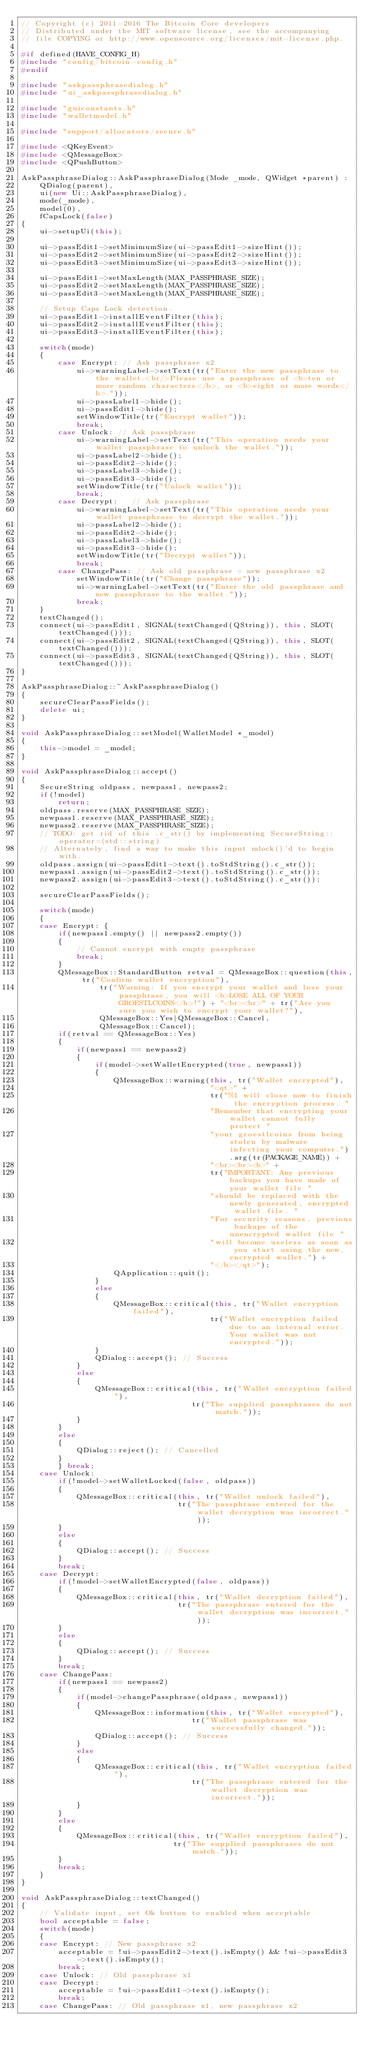Convert code to text. <code><loc_0><loc_0><loc_500><loc_500><_C++_>// Copyright (c) 2011-2016 The Bitcoin Core developers
// Distributed under the MIT software license, see the accompanying
// file COPYING or http://www.opensource.org/licenses/mit-license.php.

#if defined(HAVE_CONFIG_H)
#include "config/bitcoin-config.h"
#endif

#include "askpassphrasedialog.h"
#include "ui_askpassphrasedialog.h"

#include "guiconstants.h"
#include "walletmodel.h"

#include "support/allocators/secure.h"

#include <QKeyEvent>
#include <QMessageBox>
#include <QPushButton>

AskPassphraseDialog::AskPassphraseDialog(Mode _mode, QWidget *parent) :
    QDialog(parent),
    ui(new Ui::AskPassphraseDialog),
    mode(_mode),
    model(0),
    fCapsLock(false)
{
    ui->setupUi(this);

    ui->passEdit1->setMinimumSize(ui->passEdit1->sizeHint());
    ui->passEdit2->setMinimumSize(ui->passEdit2->sizeHint());
    ui->passEdit3->setMinimumSize(ui->passEdit3->sizeHint());

    ui->passEdit1->setMaxLength(MAX_PASSPHRASE_SIZE);
    ui->passEdit2->setMaxLength(MAX_PASSPHRASE_SIZE);
    ui->passEdit3->setMaxLength(MAX_PASSPHRASE_SIZE);

    // Setup Caps Lock detection.
    ui->passEdit1->installEventFilter(this);
    ui->passEdit2->installEventFilter(this);
    ui->passEdit3->installEventFilter(this);

    switch(mode)
    {
        case Encrypt: // Ask passphrase x2
            ui->warningLabel->setText(tr("Enter the new passphrase to the wallet.<br/>Please use a passphrase of <b>ten or more random characters</b>, or <b>eight or more words</b>."));
            ui->passLabel1->hide();
            ui->passEdit1->hide();
            setWindowTitle(tr("Encrypt wallet"));
            break;
        case Unlock: // Ask passphrase
            ui->warningLabel->setText(tr("This operation needs your wallet passphrase to unlock the wallet."));
            ui->passLabel2->hide();
            ui->passEdit2->hide();
            ui->passLabel3->hide();
            ui->passEdit3->hide();
            setWindowTitle(tr("Unlock wallet"));
            break;
        case Decrypt:   // Ask passphrase
            ui->warningLabel->setText(tr("This operation needs your wallet passphrase to decrypt the wallet."));
            ui->passLabel2->hide();
            ui->passEdit2->hide();
            ui->passLabel3->hide();
            ui->passEdit3->hide();
            setWindowTitle(tr("Decrypt wallet"));
            break;
        case ChangePass: // Ask old passphrase + new passphrase x2
            setWindowTitle(tr("Change passphrase"));
            ui->warningLabel->setText(tr("Enter the old passphrase and new passphrase to the wallet."));
            break;
    }
    textChanged();
    connect(ui->passEdit1, SIGNAL(textChanged(QString)), this, SLOT(textChanged()));
    connect(ui->passEdit2, SIGNAL(textChanged(QString)), this, SLOT(textChanged()));
    connect(ui->passEdit3, SIGNAL(textChanged(QString)), this, SLOT(textChanged()));
}

AskPassphraseDialog::~AskPassphraseDialog()
{
    secureClearPassFields();
    delete ui;
}

void AskPassphraseDialog::setModel(WalletModel *_model)
{
    this->model = _model;
}

void AskPassphraseDialog::accept()
{
    SecureString oldpass, newpass1, newpass2;
    if(!model)
        return;
    oldpass.reserve(MAX_PASSPHRASE_SIZE);
    newpass1.reserve(MAX_PASSPHRASE_SIZE);
    newpass2.reserve(MAX_PASSPHRASE_SIZE);
    // TODO: get rid of this .c_str() by implementing SecureString::operator=(std::string)
    // Alternately, find a way to make this input mlock()'d to begin with.
    oldpass.assign(ui->passEdit1->text().toStdString().c_str());
    newpass1.assign(ui->passEdit2->text().toStdString().c_str());
    newpass2.assign(ui->passEdit3->text().toStdString().c_str());

    secureClearPassFields();

    switch(mode)
    {
    case Encrypt: {
        if(newpass1.empty() || newpass2.empty())
        {
            // Cannot encrypt with empty passphrase
            break;
        }
        QMessageBox::StandardButton retval = QMessageBox::question(this, tr("Confirm wallet encryption"),
                 tr("Warning: If you encrypt your wallet and lose your passphrase, you will <b>LOSE ALL OF YOUR GROESTLCOINS</b>!") + "<br><br>" + tr("Are you sure you wish to encrypt your wallet?"),
                 QMessageBox::Yes|QMessageBox::Cancel,
                 QMessageBox::Cancel);
        if(retval == QMessageBox::Yes)
        {
            if(newpass1 == newpass2)
            {
                if(model->setWalletEncrypted(true, newpass1))
                {
                    QMessageBox::warning(this, tr("Wallet encrypted"),
                                         "<qt>" +
                                         tr("%1 will close now to finish the encryption process. "
                                         "Remember that encrypting your wallet cannot fully protect "
                                         "your groestlcoins from being stolen by malware infecting your computer.").arg(tr(PACKAGE_NAME)) +
                                         "<br><br><b>" +
                                         tr("IMPORTANT: Any previous backups you have made of your wallet file "
                                         "should be replaced with the newly generated, encrypted wallet file. "
                                         "For security reasons, previous backups of the unencrypted wallet file "
                                         "will become useless as soon as you start using the new, encrypted wallet.") +
                                         "</b></qt>");
                    QApplication::quit();
                }
                else
                {
                    QMessageBox::critical(this, tr("Wallet encryption failed"),
                                         tr("Wallet encryption failed due to an internal error. Your wallet was not encrypted."));
                }
                QDialog::accept(); // Success
            }
            else
            {
                QMessageBox::critical(this, tr("Wallet encryption failed"),
                                     tr("The supplied passphrases do not match."));
            }
        }
        else
        {
            QDialog::reject(); // Cancelled
        }
        } break;
    case Unlock:
        if(!model->setWalletLocked(false, oldpass))
        {
            QMessageBox::critical(this, tr("Wallet unlock failed"),
                                  tr("The passphrase entered for the wallet decryption was incorrect."));
        }
        else
        {
            QDialog::accept(); // Success
        }
        break;
    case Decrypt:
        if(!model->setWalletEncrypted(false, oldpass))
        {
            QMessageBox::critical(this, tr("Wallet decryption failed"),
                                  tr("The passphrase entered for the wallet decryption was incorrect."));
        }
        else
        {
            QDialog::accept(); // Success
        }
        break;
    case ChangePass:
        if(newpass1 == newpass2)
        {
            if(model->changePassphrase(oldpass, newpass1))
            {
                QMessageBox::information(this, tr("Wallet encrypted"),
                                     tr("Wallet passphrase was successfully changed."));
                QDialog::accept(); // Success
            }
            else
            {
                QMessageBox::critical(this, tr("Wallet encryption failed"),
                                     tr("The passphrase entered for the wallet decryption was incorrect."));
            }
        }
        else
        {
            QMessageBox::critical(this, tr("Wallet encryption failed"),
                                 tr("The supplied passphrases do not match."));
        }
        break;
    }
}

void AskPassphraseDialog::textChanged()
{
    // Validate input, set Ok button to enabled when acceptable
    bool acceptable = false;
    switch(mode)
    {
    case Encrypt: // New passphrase x2
        acceptable = !ui->passEdit2->text().isEmpty() && !ui->passEdit3->text().isEmpty();
        break;
    case Unlock: // Old passphrase x1
    case Decrypt:
        acceptable = !ui->passEdit1->text().isEmpty();
        break;
    case ChangePass: // Old passphrase x1, new passphrase x2</code> 